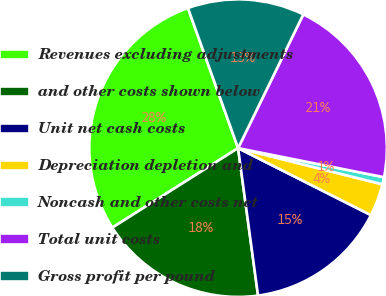Convert chart to OTSL. <chart><loc_0><loc_0><loc_500><loc_500><pie_chart><fcel>Revenues excluding adjustments<fcel>and other costs shown below<fcel>Unit net cash costs<fcel>Depreciation depletion and<fcel>Noncash and other costs net<fcel>Total unit costs<fcel>Gross profit per pound<nl><fcel>28.5%<fcel>18.17%<fcel>15.43%<fcel>3.52%<fcel>0.78%<fcel>20.91%<fcel>12.69%<nl></chart> 